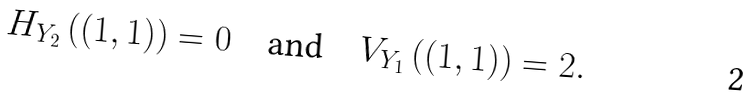Convert formula to latex. <formula><loc_0><loc_0><loc_500><loc_500>H _ { Y _ { 2 } } \left ( ( 1 , 1 ) \right ) = 0 \quad \text {and} \quad V _ { Y _ { 1 } } \left ( ( 1 , 1 ) \right ) = 2 .</formula> 